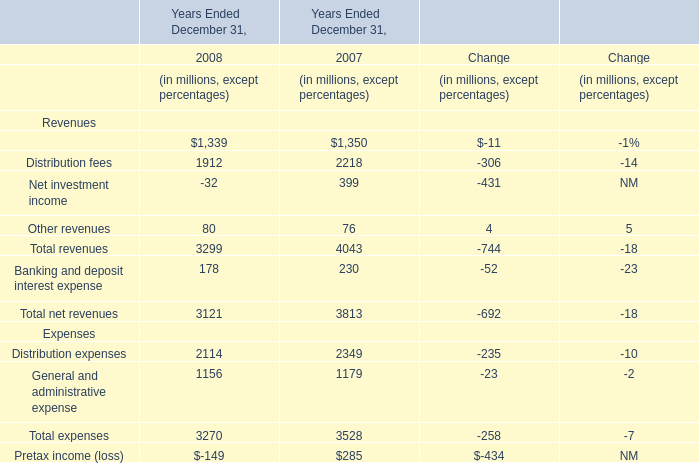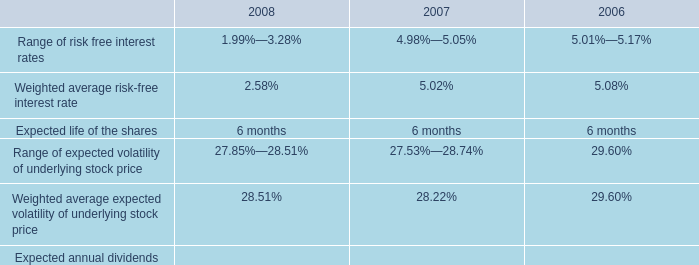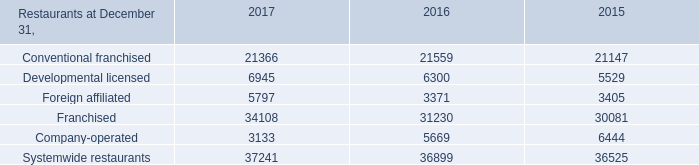How many distribution fees exceed the average of distribution fees in 2008 and 2007? 
Answer: 1. 